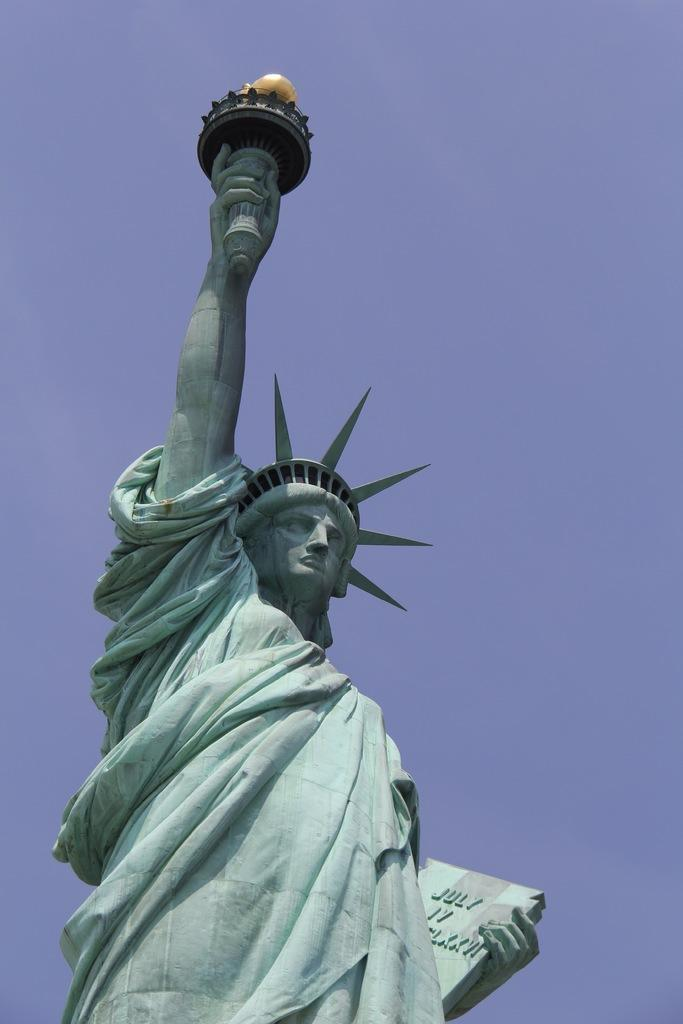What is the main subject of the image? There is a statue of liberty in the image. What can be seen in the background of the image? There is a sky visible in the background of the image. Where is the playground located in the image? There is no playground present in the image. Can you see a robin taking a bite out of the statue of liberty in the image? There is no robin or any other animal visible in the image, and the statue of liberty is not being bitten into. 